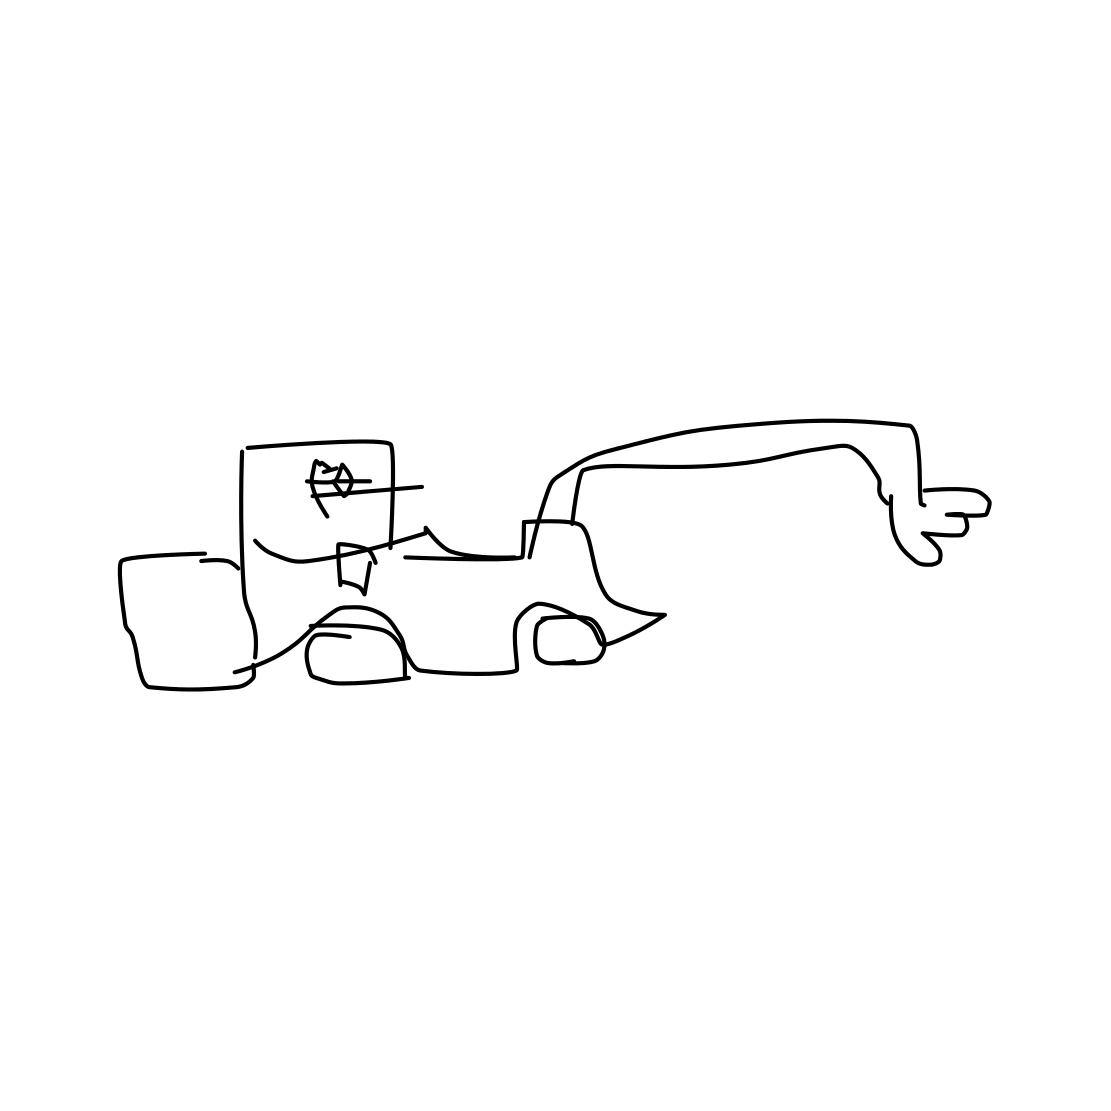Is this a canoe in the image? The image does not depict a canoe. It appears to be a simple line drawing of a car, characterized by a basic outline of wheels and windows, lacking the shape and structure of a canoe. 